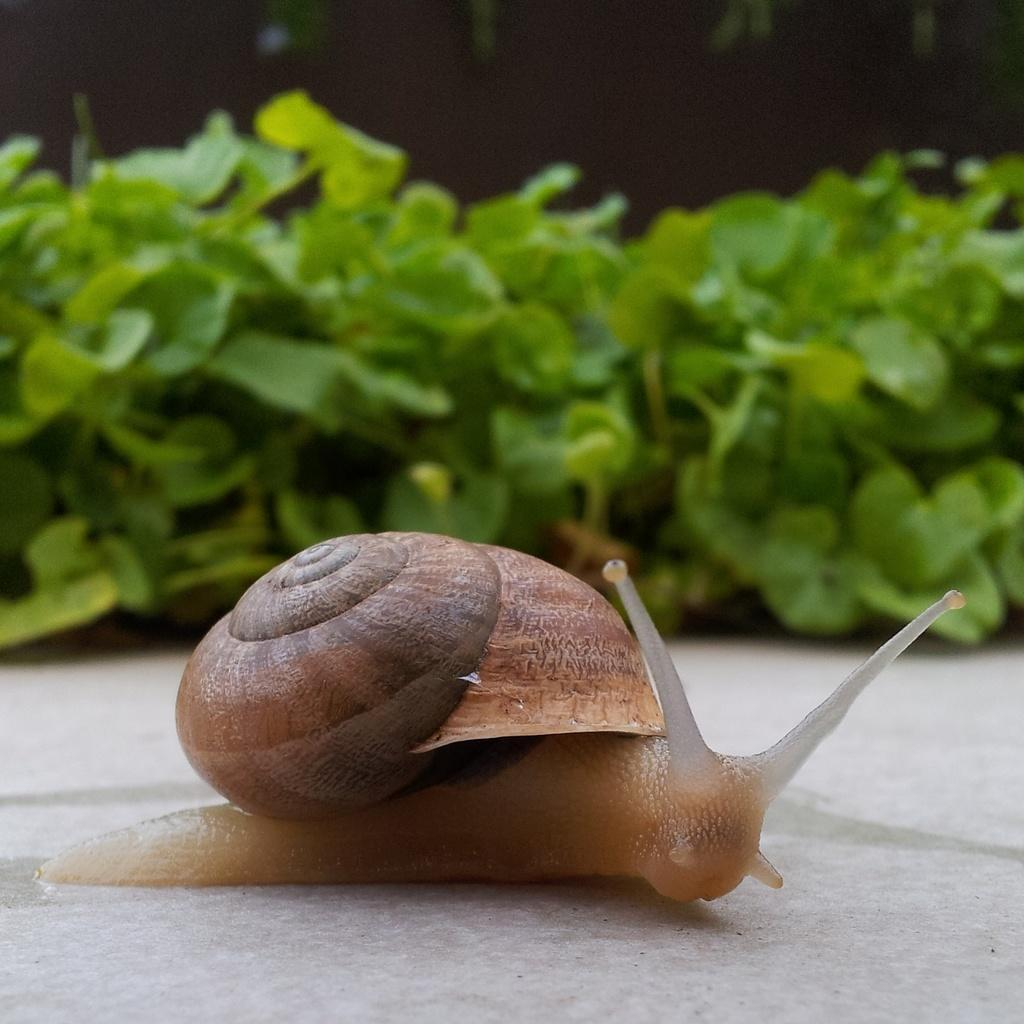What is the main subject in the center of the image? There is a snail in the center of the image. What can be seen in the background of the image? There are plants in the background of the image. What type of blood is visible on the snail in the image? There is no blood visible on the snail in the image. What kind of flower is blooming next to the snail in the image? There is no flower present in the image; it only features a snail and plants in the background. 